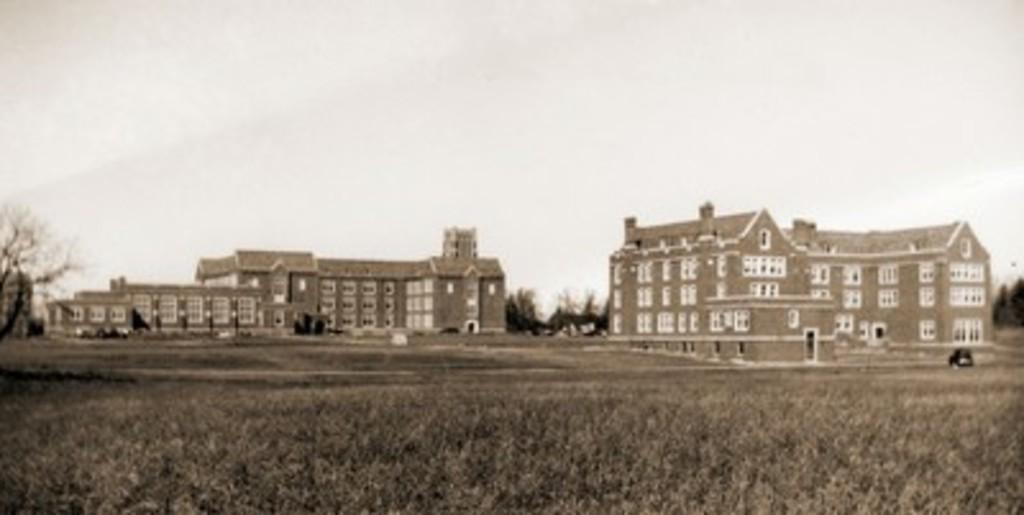In one or two sentences, can you explain what this image depicts? This is a black and white picture, in the back there are two buildings on the grassland and there are trees behind it. 